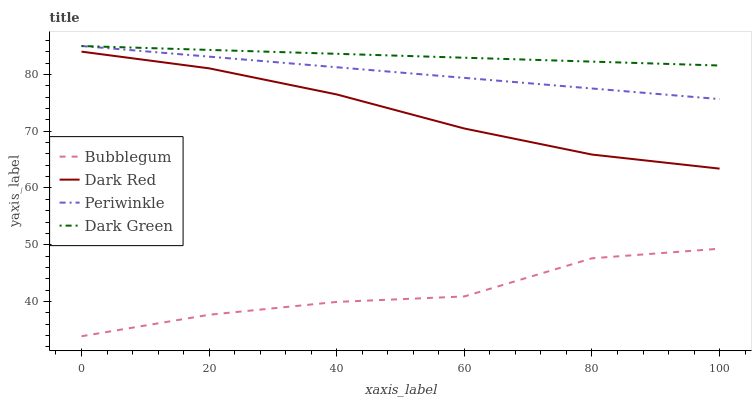Does Bubblegum have the minimum area under the curve?
Answer yes or no. Yes. Does Dark Green have the maximum area under the curve?
Answer yes or no. Yes. Does Periwinkle have the minimum area under the curve?
Answer yes or no. No. Does Periwinkle have the maximum area under the curve?
Answer yes or no. No. Is Periwinkle the smoothest?
Answer yes or no. Yes. Is Bubblegum the roughest?
Answer yes or no. Yes. Is Bubblegum the smoothest?
Answer yes or no. No. Is Periwinkle the roughest?
Answer yes or no. No. Does Bubblegum have the lowest value?
Answer yes or no. Yes. Does Periwinkle have the lowest value?
Answer yes or no. No. Does Dark Green have the highest value?
Answer yes or no. Yes. Does Bubblegum have the highest value?
Answer yes or no. No. Is Dark Red less than Periwinkle?
Answer yes or no. Yes. Is Periwinkle greater than Bubblegum?
Answer yes or no. Yes. Does Dark Green intersect Periwinkle?
Answer yes or no. Yes. Is Dark Green less than Periwinkle?
Answer yes or no. No. Is Dark Green greater than Periwinkle?
Answer yes or no. No. Does Dark Red intersect Periwinkle?
Answer yes or no. No. 